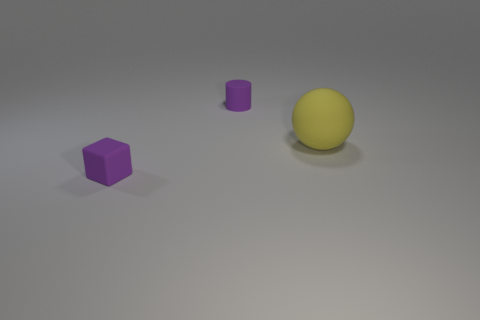How many cyan objects are small cylinders or small blocks?
Make the answer very short. 0. There is a big object that is in front of the purple rubber cylinder; what is its shape?
Your answer should be very brief. Sphere. What is the color of the matte cube that is the same size as the purple cylinder?
Provide a short and direct response. Purple. Does the large rubber thing have the same shape as the tiny rubber object that is behind the big rubber ball?
Ensure brevity in your answer.  No. There is a purple object on the left side of the purple object that is to the right of the tiny purple thing that is in front of the tiny matte cylinder; what is its material?
Offer a terse response. Rubber. How many tiny things are purple blocks or cyan cylinders?
Ensure brevity in your answer.  1. What number of other things are there of the same size as the yellow sphere?
Offer a very short reply. 0. Is there anything else that is the same shape as the big yellow thing?
Your answer should be very brief. No. Are there the same number of tiny purple matte cubes that are in front of the purple cube and tiny cyan spheres?
Make the answer very short. Yes. How many tiny objects are both in front of the big yellow sphere and behind the large matte sphere?
Your response must be concise. 0. 